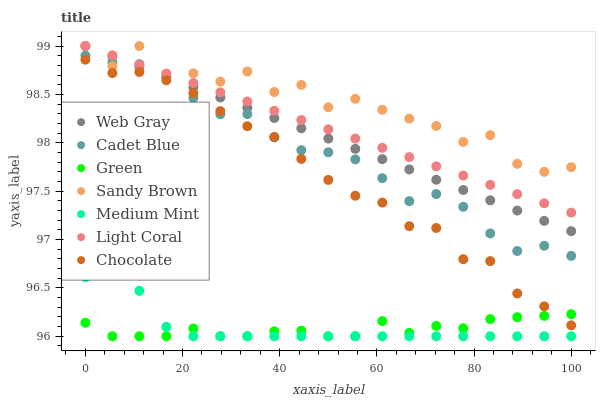Does Green have the minimum area under the curve?
Answer yes or no. Yes. Does Sandy Brown have the maximum area under the curve?
Answer yes or no. Yes. Does Cadet Blue have the minimum area under the curve?
Answer yes or no. No. Does Cadet Blue have the maximum area under the curve?
Answer yes or no. No. Is Light Coral the smoothest?
Answer yes or no. Yes. Is Sandy Brown the roughest?
Answer yes or no. Yes. Is Cadet Blue the smoothest?
Answer yes or no. No. Is Cadet Blue the roughest?
Answer yes or no. No. Does Medium Mint have the lowest value?
Answer yes or no. Yes. Does Cadet Blue have the lowest value?
Answer yes or no. No. Does Sandy Brown have the highest value?
Answer yes or no. Yes. Does Cadet Blue have the highest value?
Answer yes or no. No. Is Chocolate less than Web Gray?
Answer yes or no. Yes. Is Web Gray greater than Chocolate?
Answer yes or no. Yes. Does Light Coral intersect Sandy Brown?
Answer yes or no. Yes. Is Light Coral less than Sandy Brown?
Answer yes or no. No. Is Light Coral greater than Sandy Brown?
Answer yes or no. No. Does Chocolate intersect Web Gray?
Answer yes or no. No. 